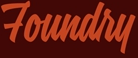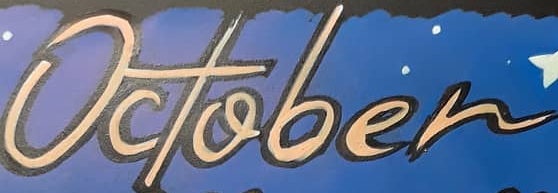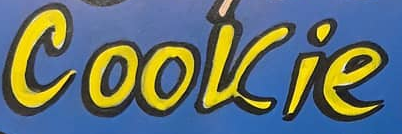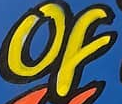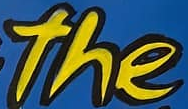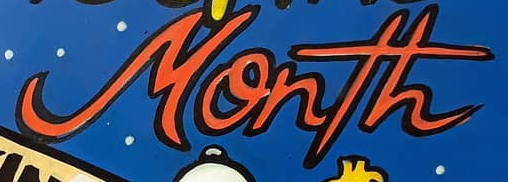Identify the words shown in these images in order, separated by a semicolon. Foundry; October; Cookie; of; the; Month 